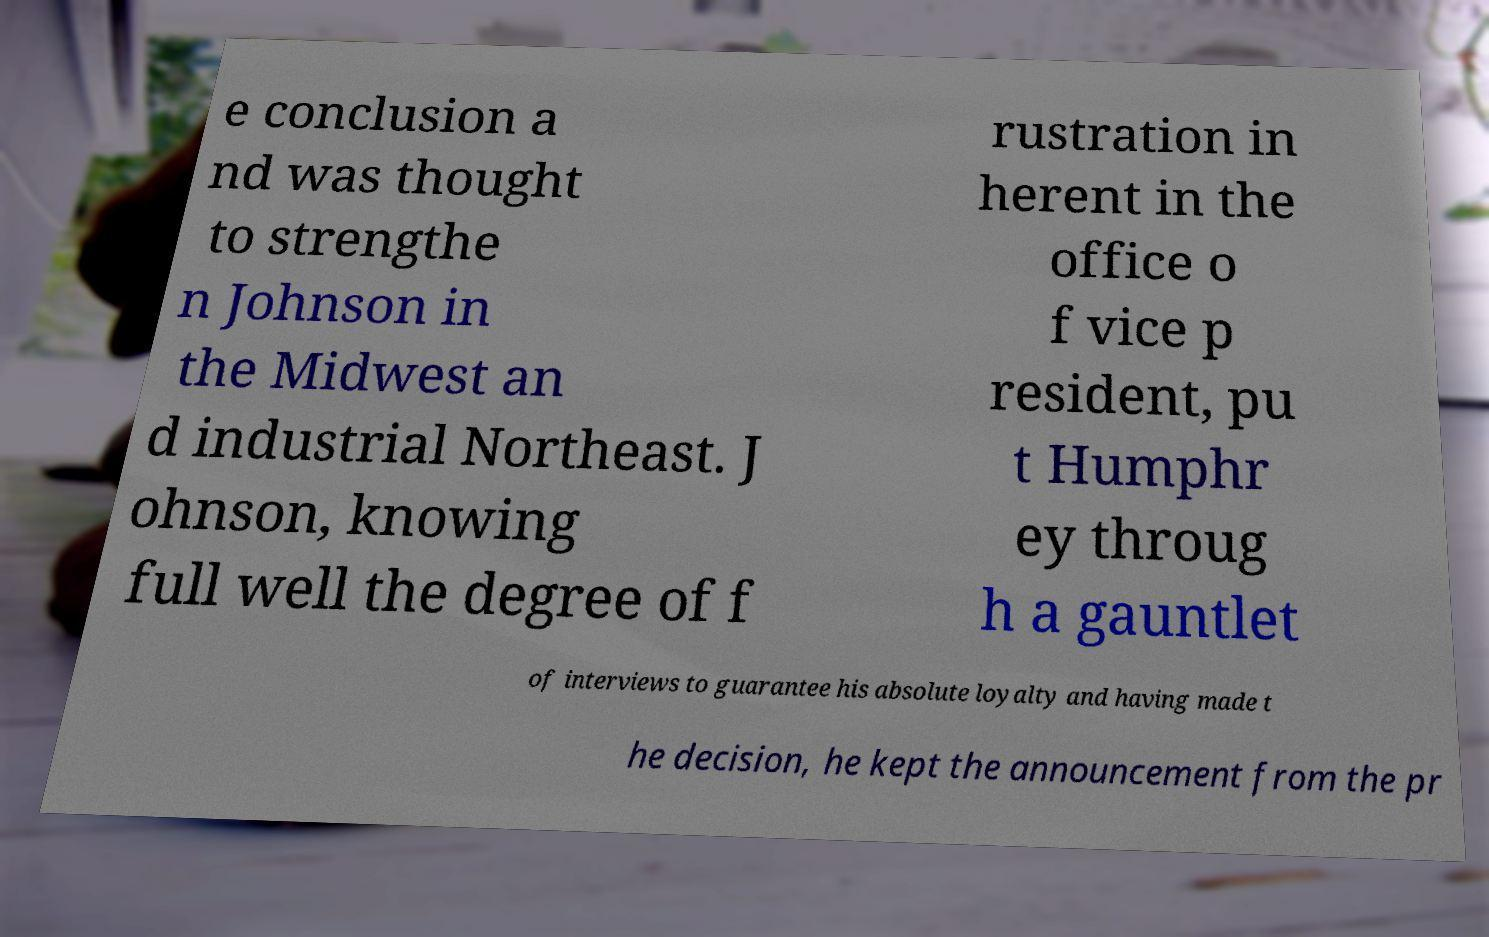Could you extract and type out the text from this image? e conclusion a nd was thought to strengthe n Johnson in the Midwest an d industrial Northeast. J ohnson, knowing full well the degree of f rustration in herent in the office o f vice p resident, pu t Humphr ey throug h a gauntlet of interviews to guarantee his absolute loyalty and having made t he decision, he kept the announcement from the pr 